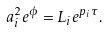Convert formula to latex. <formula><loc_0><loc_0><loc_500><loc_500>a _ { i } ^ { 2 } e ^ { \phi } = L _ { i } e ^ { p _ { i } \tau } .</formula> 